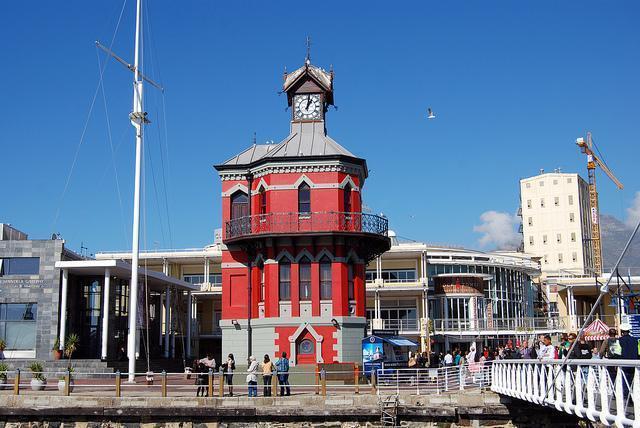What color are the rectangular bricks on the very bottom of the tower?
Pick the right solution, then justify: 'Answer: answer
Rationale: rationale.'
Options: Red, white, gray, blue. Answer: gray.
Rationale: A tower is made of red and gray bricks with the gray being wider than they are tall. 